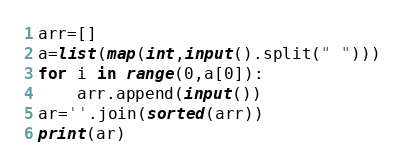<code> <loc_0><loc_0><loc_500><loc_500><_Python_>arr=[]
a=list(map(int,input().split(" ")))
for i in range(0,a[0]):
    arr.append(input())
ar=''.join(sorted(arr))
print(ar)</code> 